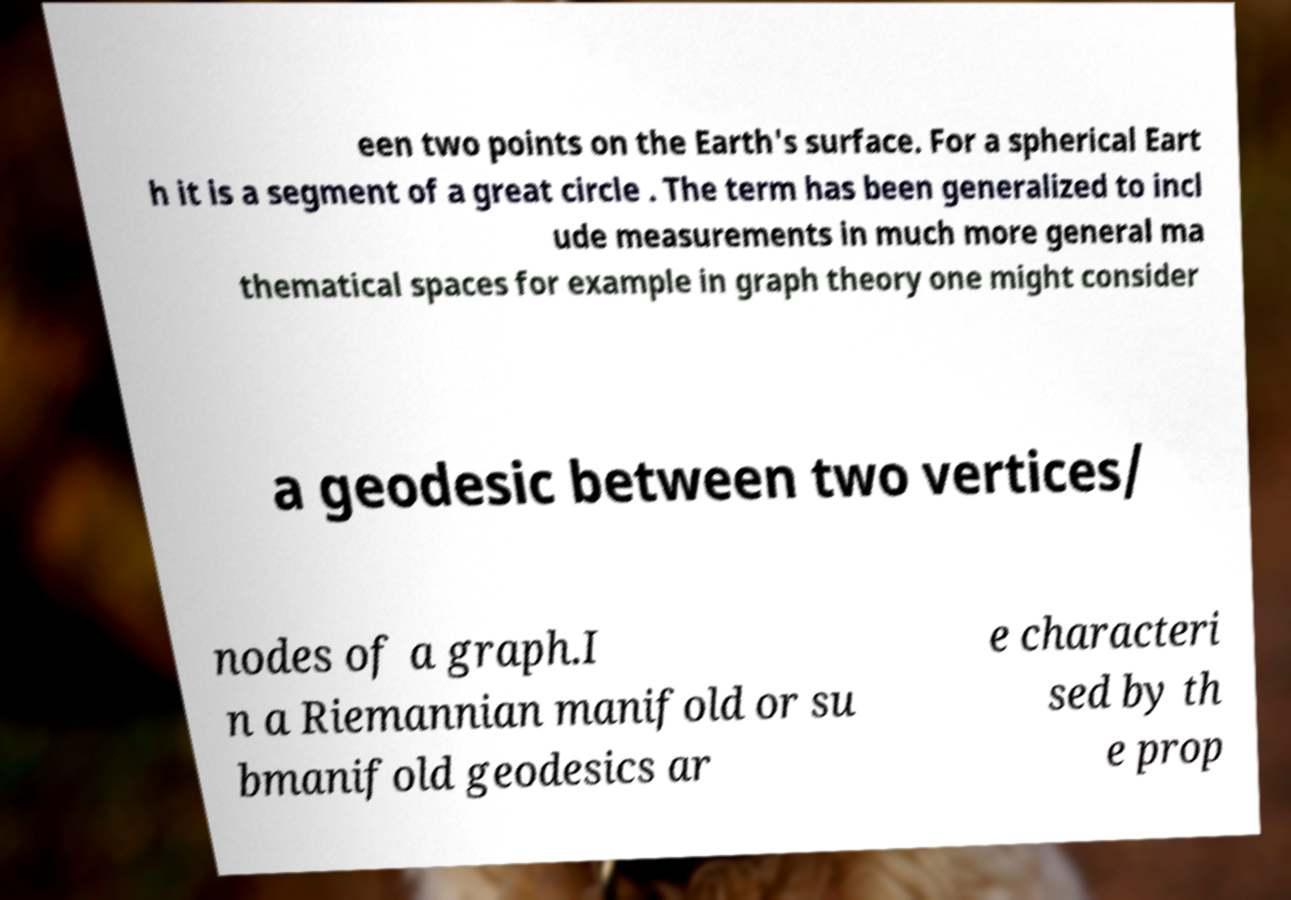What messages or text are displayed in this image? I need them in a readable, typed format. een two points on the Earth's surface. For a spherical Eart h it is a segment of a great circle . The term has been generalized to incl ude measurements in much more general ma thematical spaces for example in graph theory one might consider a geodesic between two vertices/ nodes of a graph.I n a Riemannian manifold or su bmanifold geodesics ar e characteri sed by th e prop 